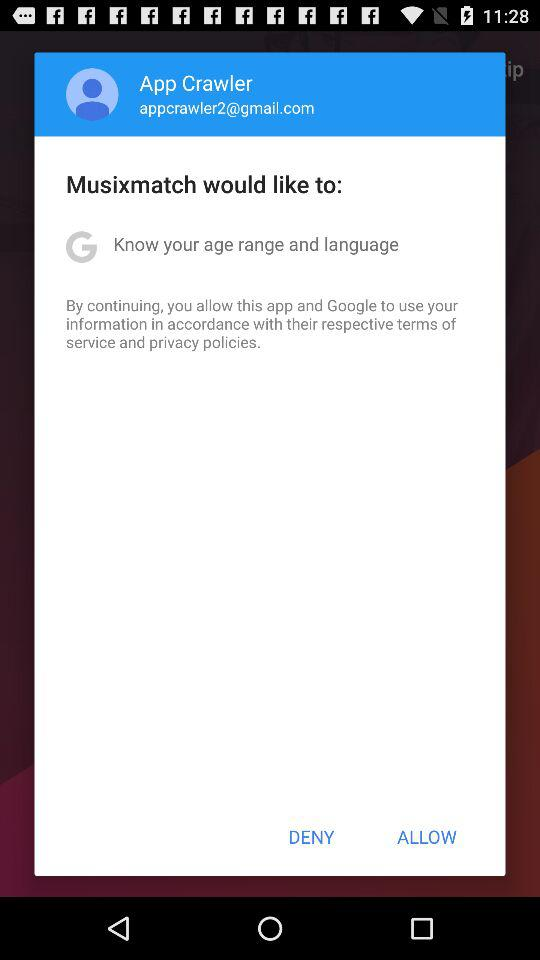What is the username? The user name is App Crawler. 